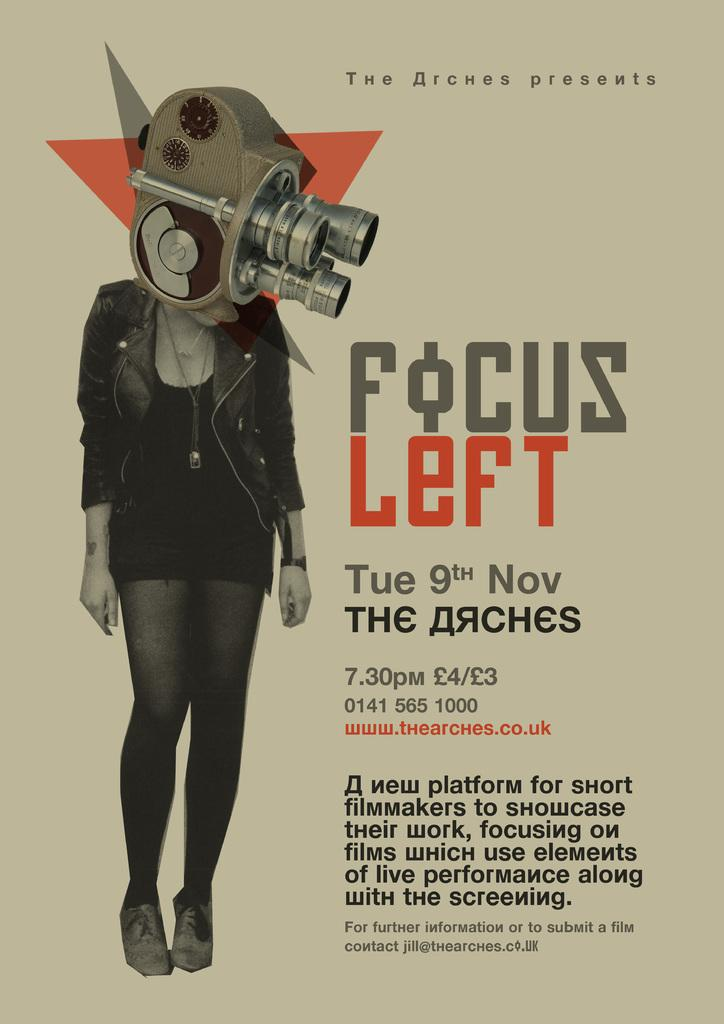<image>
Summarize the visual content of the image. Poster showing a woman with a telescope head and the words "Focus Left". 